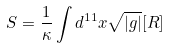<formula> <loc_0><loc_0><loc_500><loc_500>S = \frac { 1 } { \kappa } \int d ^ { 1 1 } x \sqrt { | g | } [ R ]</formula> 